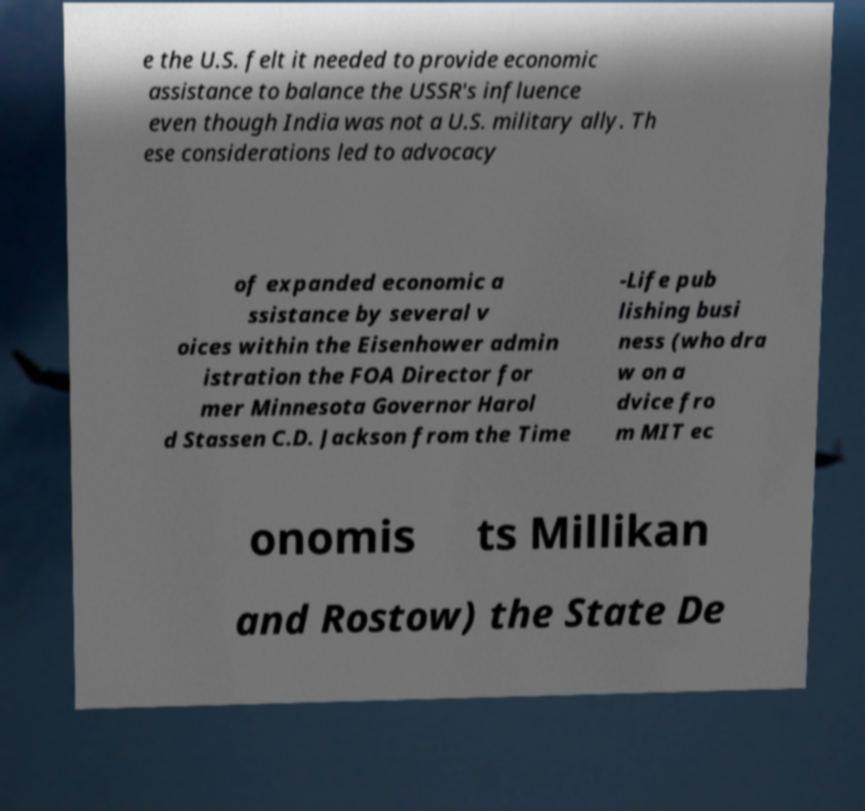Please identify and transcribe the text found in this image. e the U.S. felt it needed to provide economic assistance to balance the USSR's influence even though India was not a U.S. military ally. Th ese considerations led to advocacy of expanded economic a ssistance by several v oices within the Eisenhower admin istration the FOA Director for mer Minnesota Governor Harol d Stassen C.D. Jackson from the Time -Life pub lishing busi ness (who dra w on a dvice fro m MIT ec onomis ts Millikan and Rostow) the State De 